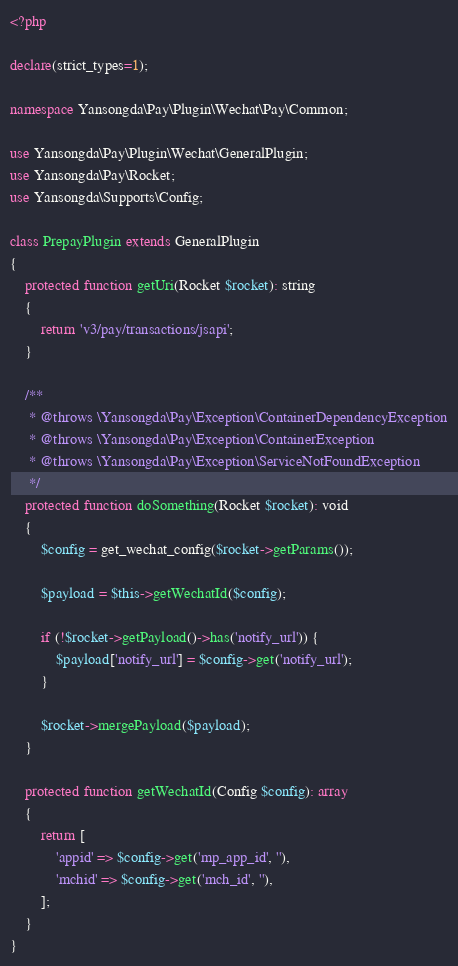<code> <loc_0><loc_0><loc_500><loc_500><_PHP_><?php

declare(strict_types=1);

namespace Yansongda\Pay\Plugin\Wechat\Pay\Common;

use Yansongda\Pay\Plugin\Wechat\GeneralPlugin;
use Yansongda\Pay\Rocket;
use Yansongda\Supports\Config;

class PrepayPlugin extends GeneralPlugin
{
    protected function getUri(Rocket $rocket): string
    {
        return 'v3/pay/transactions/jsapi';
    }

    /**
     * @throws \Yansongda\Pay\Exception\ContainerDependencyException
     * @throws \Yansongda\Pay\Exception\ContainerException
     * @throws \Yansongda\Pay\Exception\ServiceNotFoundException
     */
    protected function doSomething(Rocket $rocket): void
    {
        $config = get_wechat_config($rocket->getParams());

        $payload = $this->getWechatId($config);

        if (!$rocket->getPayload()->has('notify_url')) {
            $payload['notify_url'] = $config->get('notify_url');
        }

        $rocket->mergePayload($payload);
    }

    protected function getWechatId(Config $config): array
    {
        return [
            'appid' => $config->get('mp_app_id', ''),
            'mchid' => $config->get('mch_id', ''),
        ];
    }
}
</code> 